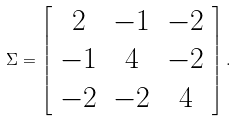Convert formula to latex. <formula><loc_0><loc_0><loc_500><loc_500>\Sigma = \left [ \begin{array} { c c c } 2 & - 1 & - 2 \\ - 1 & 4 & - 2 \\ - 2 & - 2 & 4 \\ \end{array} \right ] .</formula> 